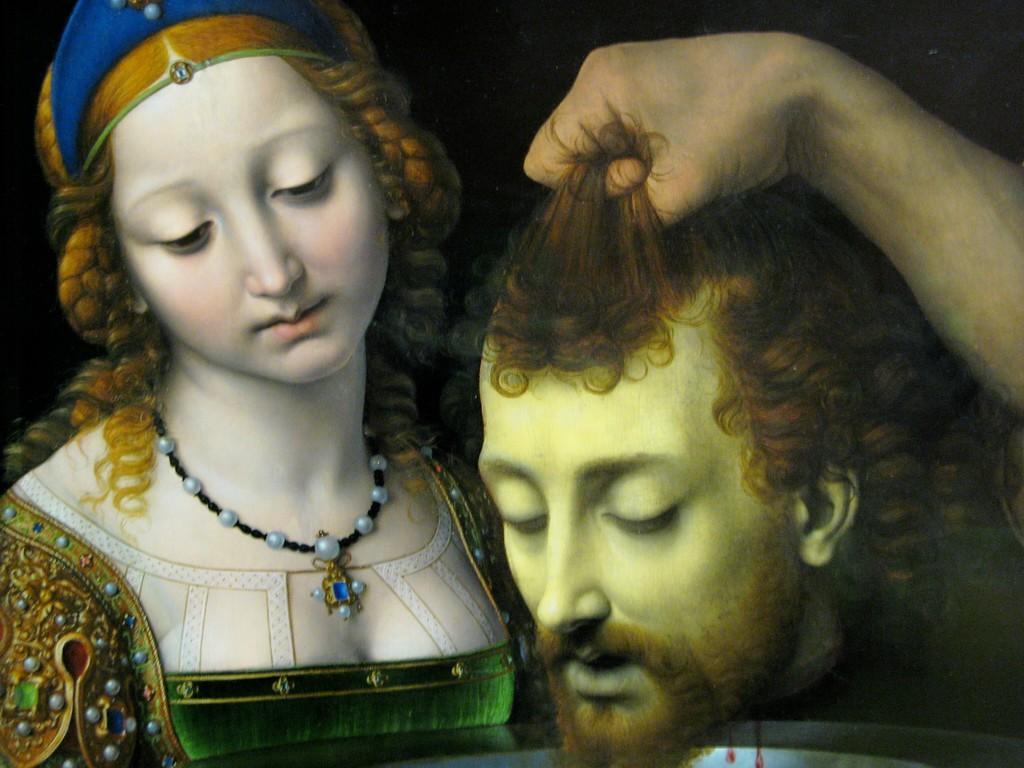Can you describe this image briefly? In this image I can see depiction picture where I can see a woman and head of a man. I can also see a hand on the right side this image. 